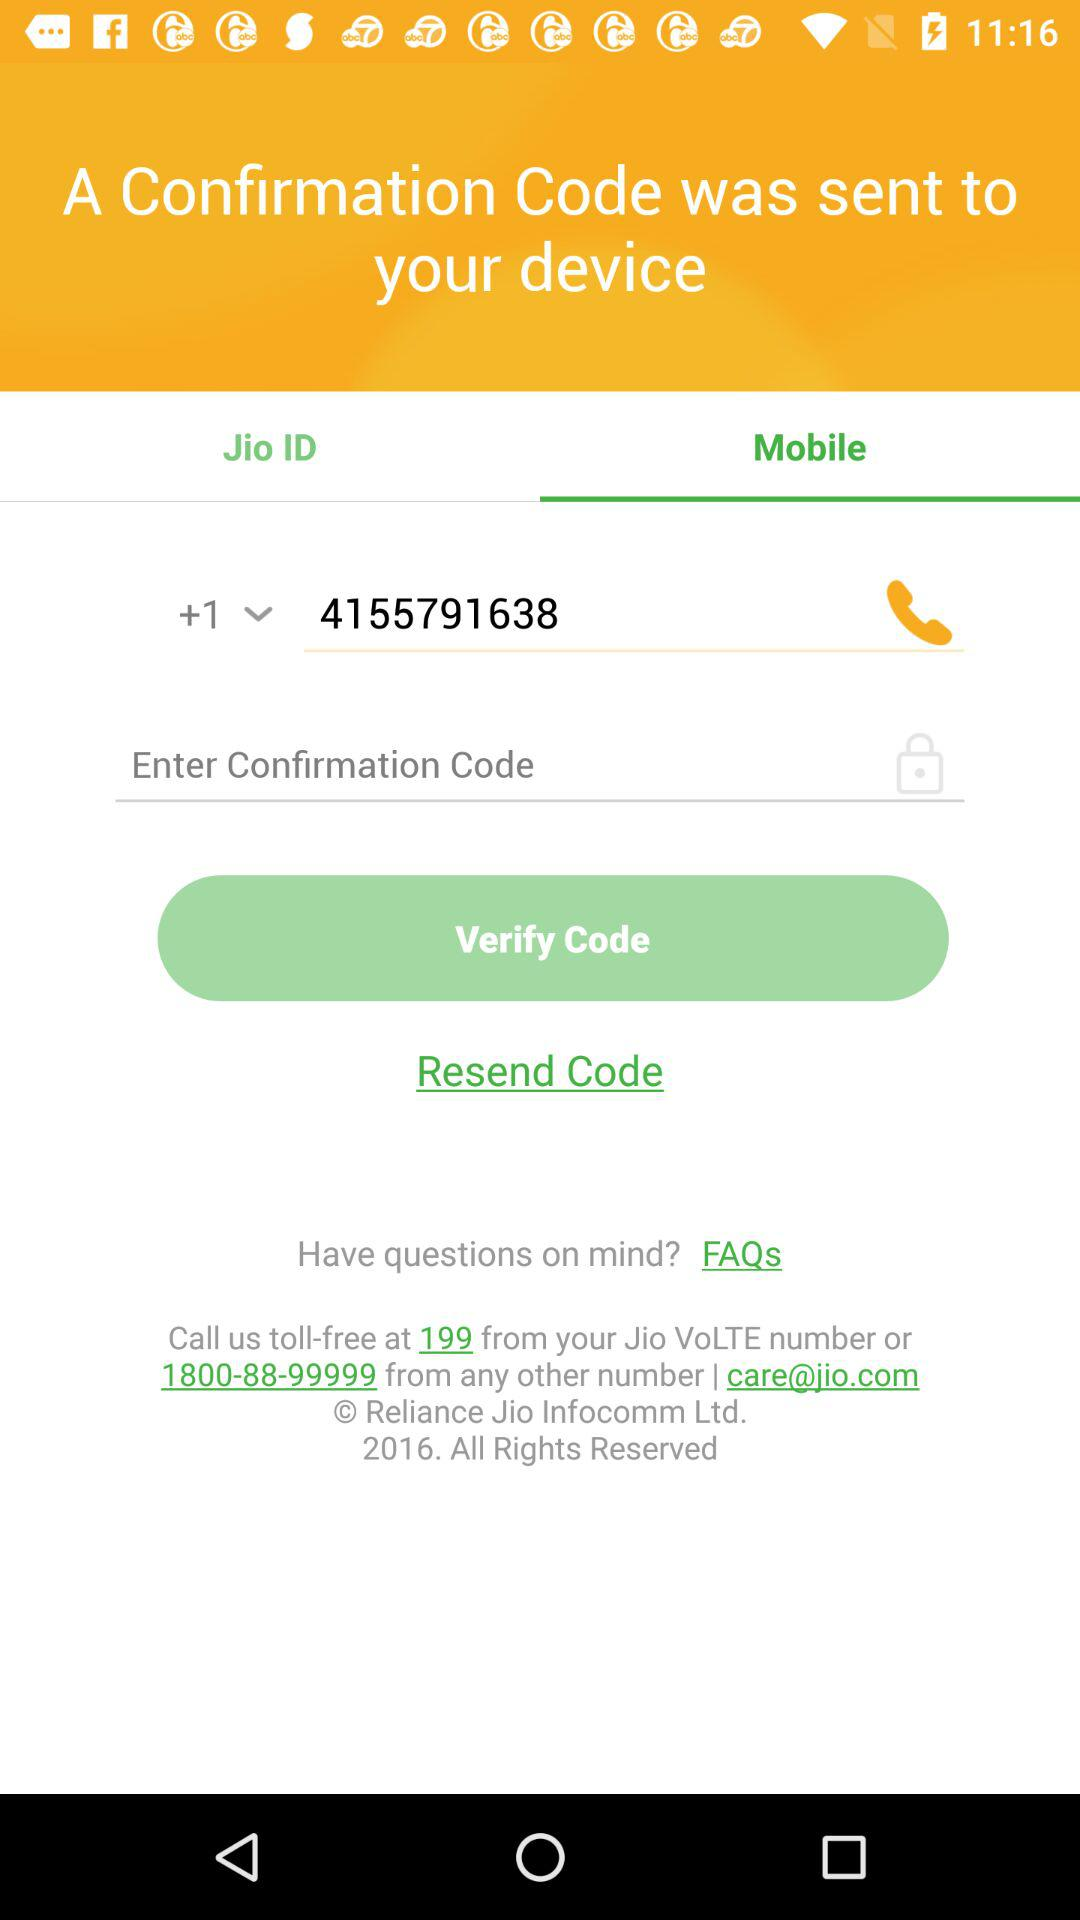What is the toll-free number? The toll-free numbers are 199 and 1800-88-99999. 